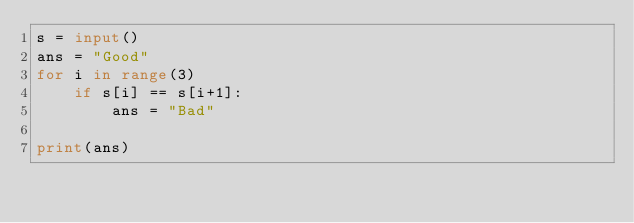<code> <loc_0><loc_0><loc_500><loc_500><_Python_>s = input()
ans = "Good"
for i in range(3)
	if s[i] == s[i+1]:
		ans = "Bad"
 
print(ans)</code> 